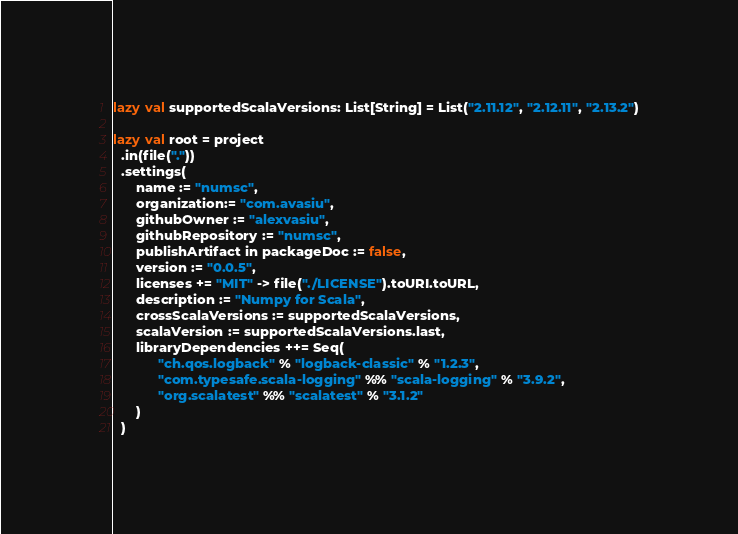<code> <loc_0><loc_0><loc_500><loc_500><_Scala_>lazy val supportedScalaVersions: List[String] = List("2.11.12", "2.12.11", "2.13.2")

lazy val root = project
  .in(file("."))
  .settings(
      name := "numsc",
      organization:= "com.avasiu",
      githubOwner := "alexvasiu",
      githubRepository := "numsc",
      publishArtifact in packageDoc := false,
      version := "0.0.5",
      licenses += "MIT" -> file("./LICENSE").toURI.toURL,
      description := "Numpy for Scala",
      crossScalaVersions := supportedScalaVersions,
      scalaVersion := supportedScalaVersions.last,
      libraryDependencies ++= Seq(
            "ch.qos.logback" % "logback-classic" % "1.2.3",
            "com.typesafe.scala-logging" %% "scala-logging" % "3.9.2",
            "org.scalatest" %% "scalatest" % "3.1.2"
      )
  )
</code> 